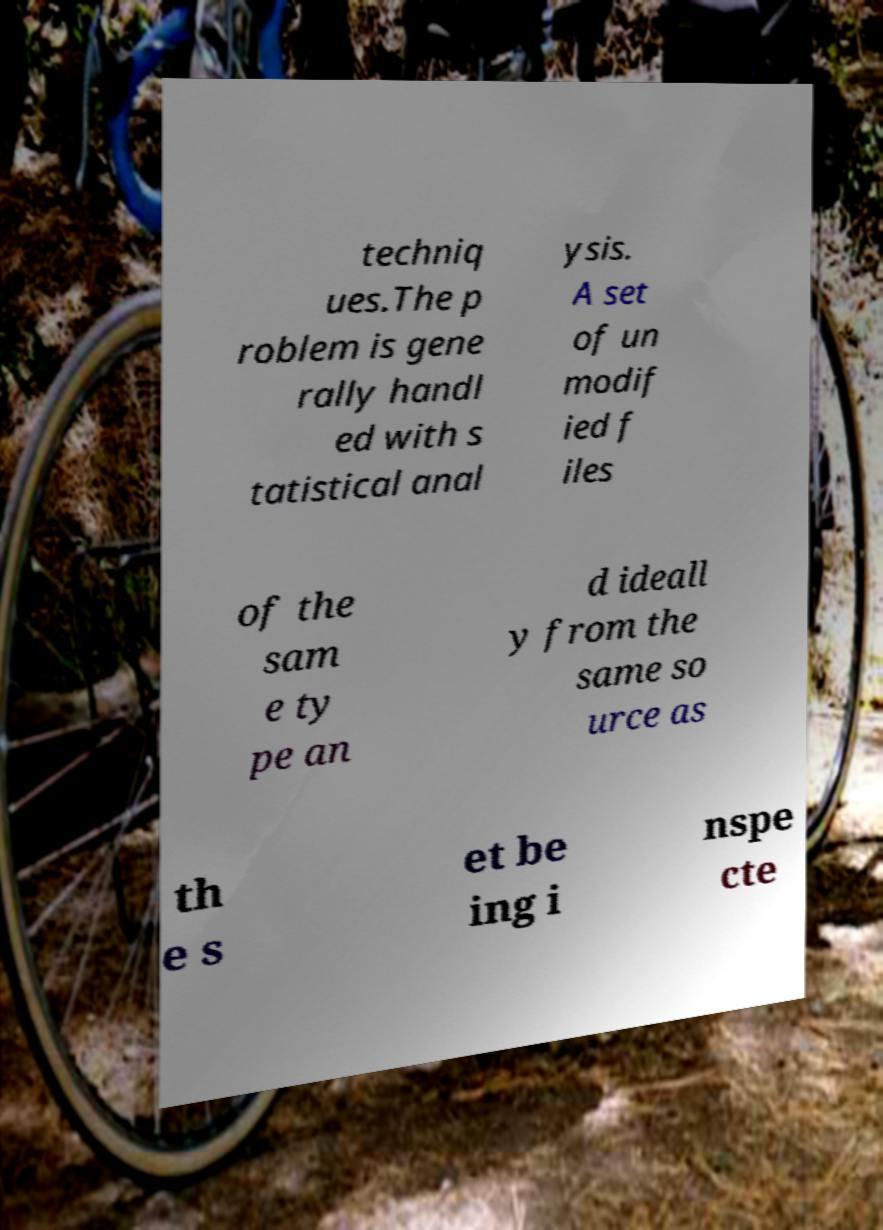Please identify and transcribe the text found in this image. techniq ues.The p roblem is gene rally handl ed with s tatistical anal ysis. A set of un modif ied f iles of the sam e ty pe an d ideall y from the same so urce as th e s et be ing i nspe cte 